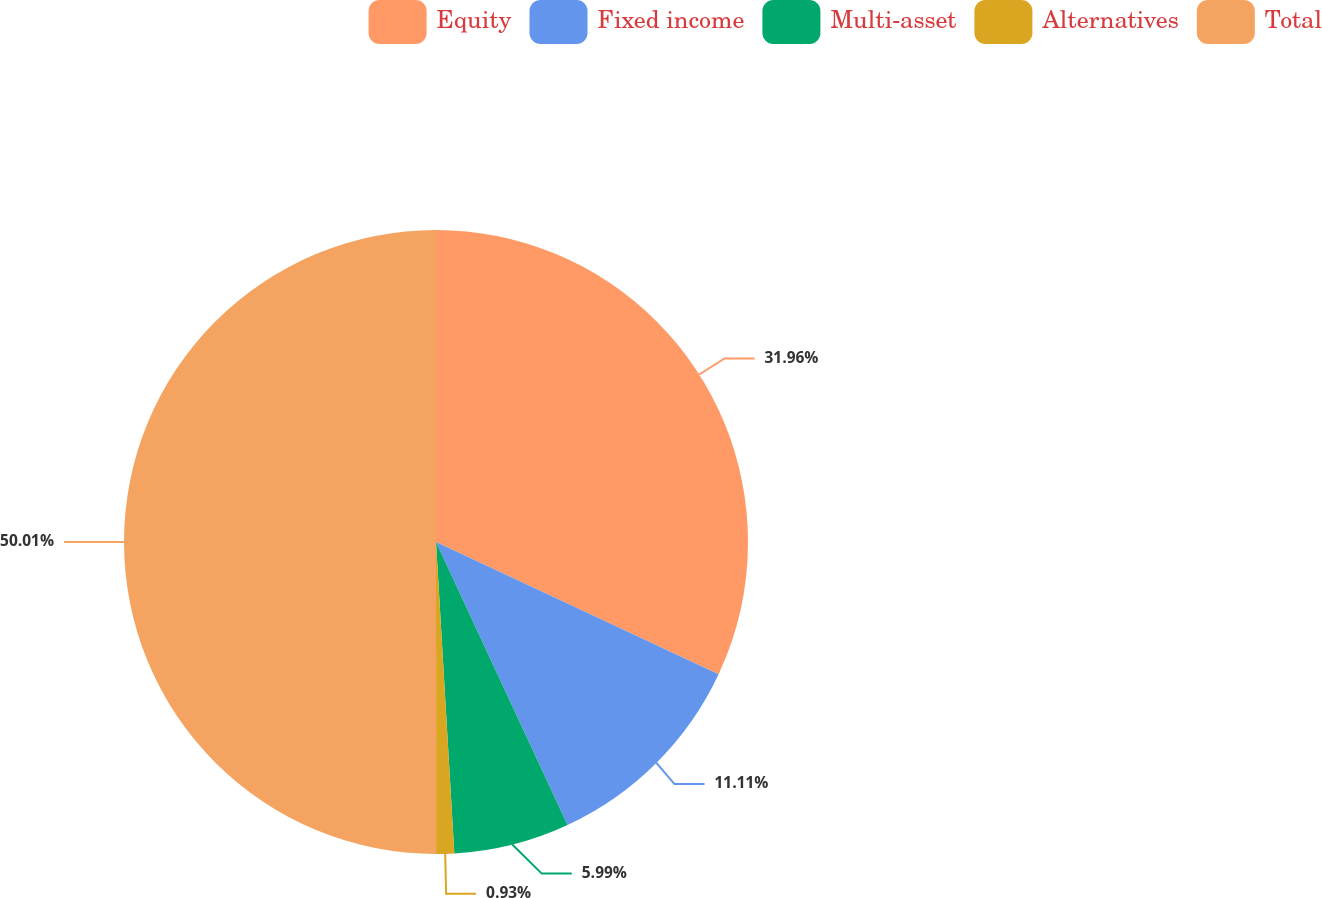<chart> <loc_0><loc_0><loc_500><loc_500><pie_chart><fcel>Equity<fcel>Fixed income<fcel>Multi-asset<fcel>Alternatives<fcel>Total<nl><fcel>31.96%<fcel>11.11%<fcel>5.99%<fcel>0.93%<fcel>50.0%<nl></chart> 